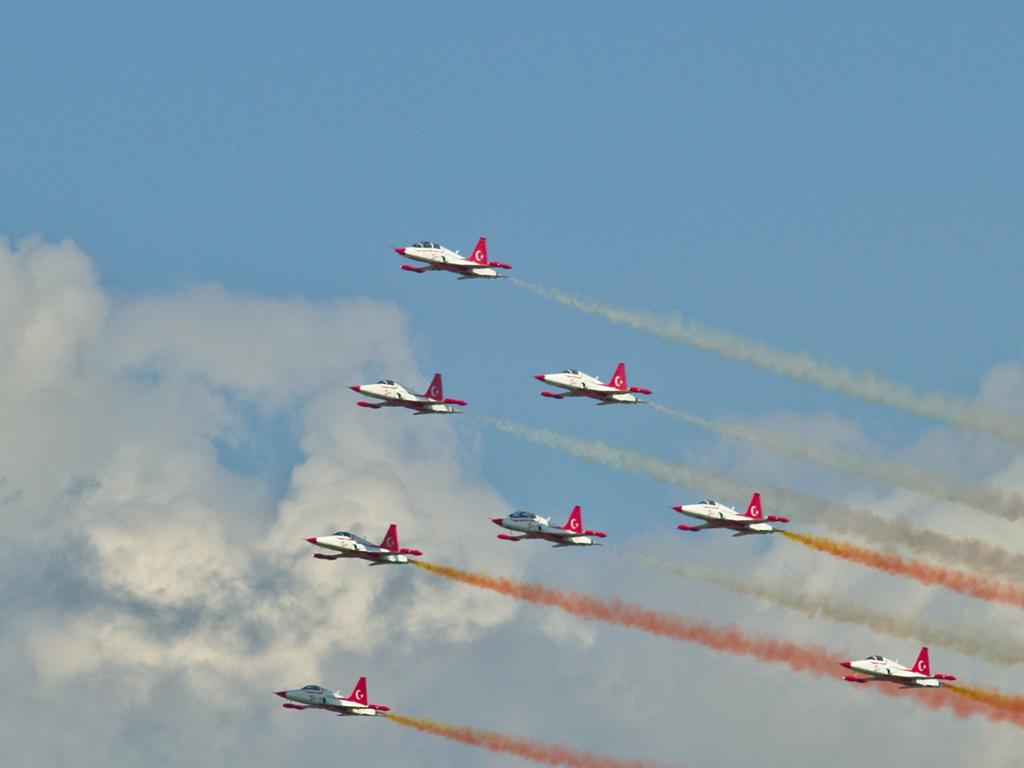Could you give a brief overview of what you see in this image? There are white color aircraft, emitting smoke and flying in the air. In the background, there are clouds in the blue sky. 